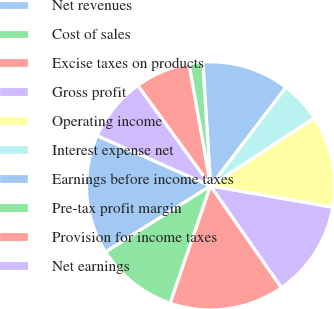Convert chart. <chart><loc_0><loc_0><loc_500><loc_500><pie_chart><fcel>Net revenues<fcel>Cost of sales<fcel>Excise taxes on products<fcel>Gross profit<fcel>Operating income<fcel>Interest expense net<fcel>Earnings before income taxes<fcel>Pre-tax profit margin<fcel>Provision for income taxes<fcel>Net earnings<nl><fcel>15.57%<fcel>10.78%<fcel>14.97%<fcel>12.57%<fcel>11.98%<fcel>5.39%<fcel>11.38%<fcel>1.8%<fcel>7.19%<fcel>8.38%<nl></chart> 